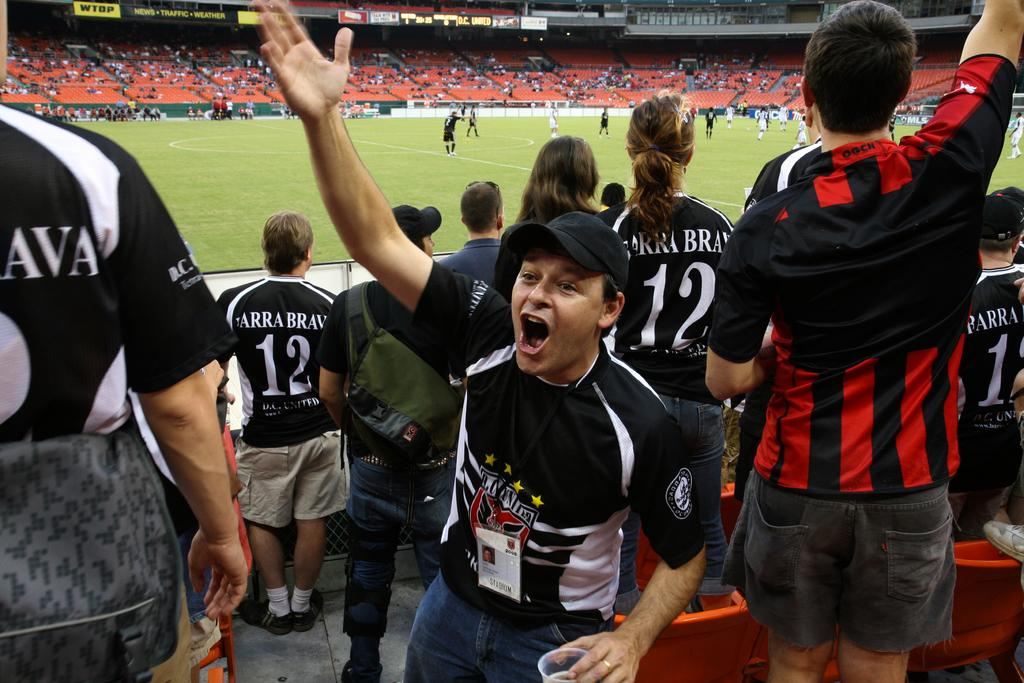<image>
Write a terse but informative summary of the picture. Many fans in a stadium wear black and white jerseys of Brava #12 and cheer on their team. 